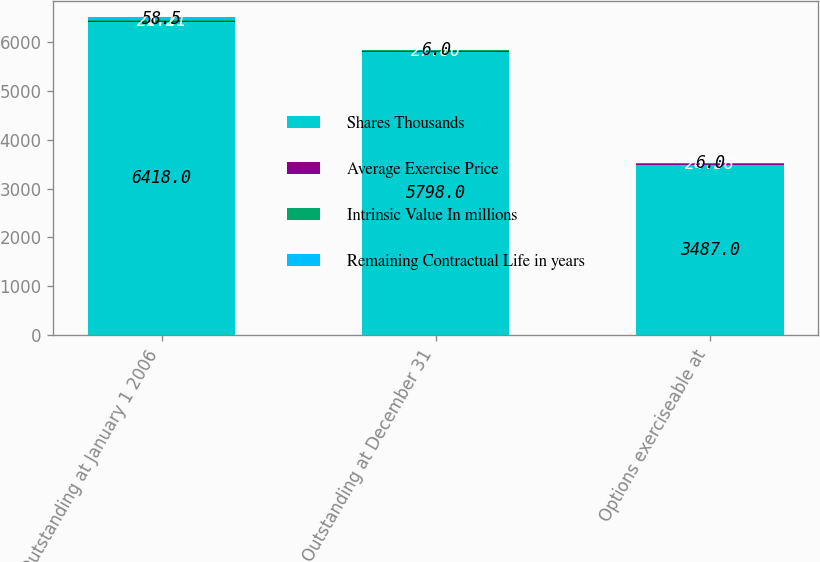Convert chart to OTSL. <chart><loc_0><loc_0><loc_500><loc_500><stacked_bar_chart><ecel><fcel>Outstanding at January 1 2006<fcel>Outstanding at December 31<fcel>Options exerciseable at<nl><fcel>Shares Thousands<fcel>6418<fcel>5798<fcel>3487<nl><fcel>Average Exercise Price<fcel>21.21<fcel>27.86<fcel>24.38<nl><fcel>Intrinsic Value In millions<fcel>8.1<fcel>6.7<fcel>5.9<nl><fcel>Remaining Contractual Life in years<fcel>58.5<fcel>6<fcel>6<nl></chart> 